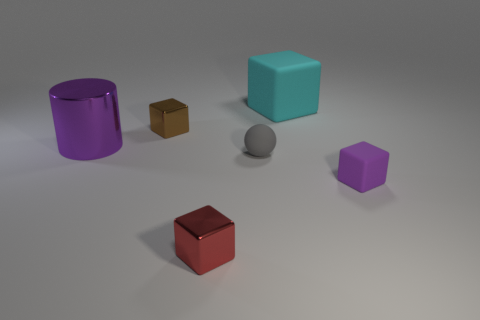Subtract all red cubes. How many cubes are left? 3 Subtract all red metal blocks. How many blocks are left? 3 Add 2 red metallic things. How many objects exist? 8 Subtract 0 red spheres. How many objects are left? 6 Subtract all spheres. How many objects are left? 5 Subtract 2 cubes. How many cubes are left? 2 Subtract all yellow blocks. Subtract all red spheres. How many blocks are left? 4 Subtract all blue cylinders. How many green balls are left? 0 Subtract all purple cubes. Subtract all tiny shiny cubes. How many objects are left? 3 Add 2 red shiny objects. How many red shiny objects are left? 3 